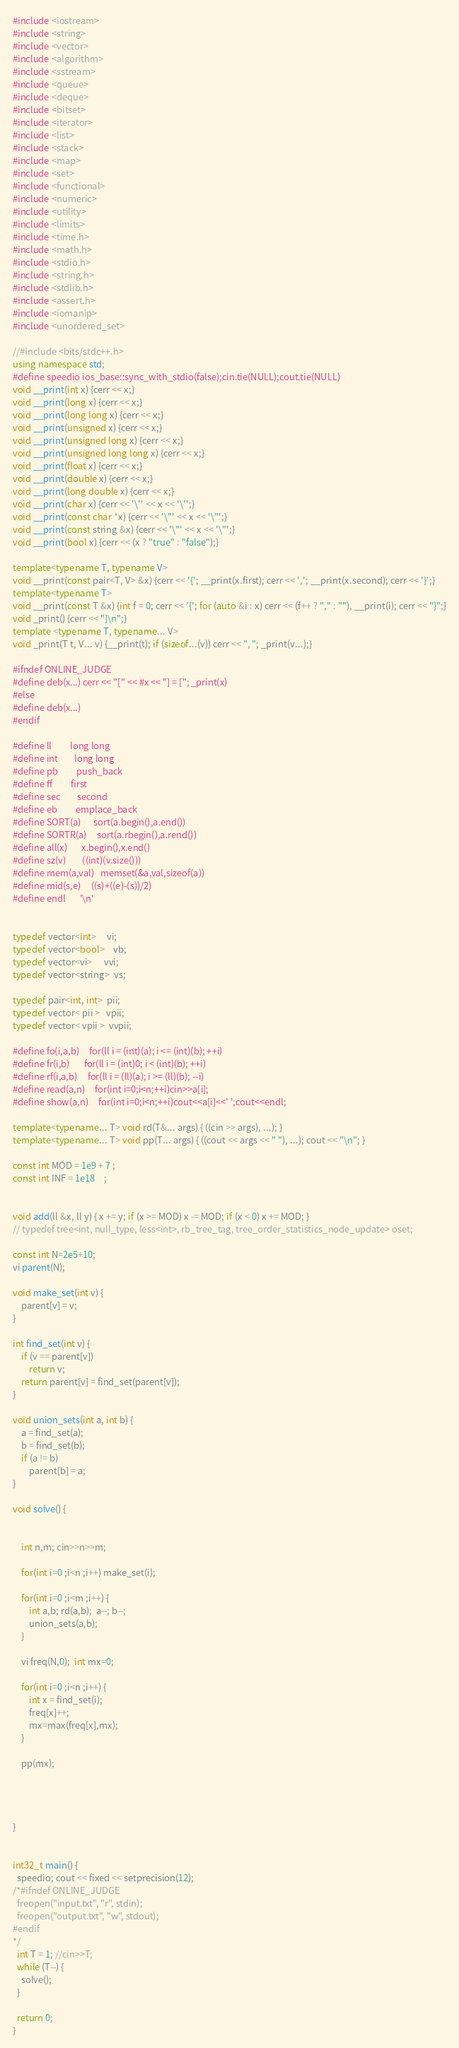<code> <loc_0><loc_0><loc_500><loc_500><_C++_>#include <iostream>
#include <string>
#include <vector>
#include <algorithm>
#include <sstream>
#include <queue>
#include <deque>
#include <bitset>
#include <iterator>
#include <list>
#include <stack>
#include <map>
#include <set>
#include <functional>
#include <numeric>
#include <utility>
#include <limits>
#include <time.h>
#include <math.h>
#include <stdio.h>
#include <string.h>
#include <stdlib.h>
#include <assert.h>
#include <iomanip>
#include <unordered_set> 

//#include <bits/stdc++.h>
using namespace std;
#define speedio ios_base::sync_with_stdio(false);cin.tie(NULL);cout.tie(NULL)
void __print(int x) {cerr << x;}
void __print(long x) {cerr << x;}
void __print(long long x) {cerr << x;}
void __print(unsigned x) {cerr << x;}
void __print(unsigned long x) {cerr << x;}
void __print(unsigned long long x) {cerr << x;}
void __print(float x) {cerr << x;}
void __print(double x) {cerr << x;}
void __print(long double x) {cerr << x;}
void __print(char x) {cerr << '\'' << x << '\'';}
void __print(const char *x) {cerr << '\"' << x << '\"';}
void __print(const string &x) {cerr << '\"' << x << '\"';}
void __print(bool x) {cerr << (x ? "true" : "false");}

template<typename T, typename V>
void __print(const pair<T, V> &x) {cerr << '{'; __print(x.first); cerr << ','; __print(x.second); cerr << '}';}
template<typename T>
void __print(const T &x) {int f = 0; cerr << '{'; for (auto &i : x) cerr << (f++ ? "," : ""), __print(i); cerr << "}";}
void _print() {cerr << "]\n";}
template <typename T, typename... V>
void _print(T t, V... v) {__print(t); if (sizeof...(v)) cerr << ", "; _print(v...);}

#ifndef ONLINE_JUDGE
#define deb(x...) cerr << "[" << #x << "] = ["; _print(x)
#else
#define deb(x...)
#endif

#define ll         long long
#define int        long long
#define pb         push_back
#define ff         first
#define sec        second
#define eb         emplace_back
#define SORT(a)      sort(a.begin(),a.end())
#define SORTR(a)     sort(a.rbegin(),a.rend())
#define all(x)       x.begin(),x.end()
#define sz(v)        ((int)(v.size()))
#define mem(a,val)   memset(&a,val,sizeof(a))
#define mid(s,e)     ((s)+((e)-(s))/2)
#define endl       '\n'


typedef vector<int>     vi;
typedef vector<bool>    vb;
typedef vector<vi>      vvi;
typedef vector<string>  vs;

typedef pair<int, int>  pii;
typedef vector< pii >   vpii;
typedef vector< vpii >  vvpii;

#define fo(i,a,b)     for(ll i = (int)(a); i <= (int)(b); ++i)
#define fr(i,b)       for(ll i = (int)0; i < (int)(b); ++i)
#define rf(i,a,b)     for(ll i = (ll)(a); i >= (ll)(b); --i)
#define read(a,n)     for(int i=0;i<n;++i)cin>>a[i];
#define show(a,n)     for(int i=0;i<n;++i)cout<<a[i]<<' ';cout<<endl;

template<typename... T> void rd(T&... args) { ((cin >> args), ...); }
template<typename... T> void pp(T... args) { ((cout << args << " "), ...); cout << "\n"; }

const int MOD = 1e9 + 7 ;
const int INF = 1e18    ;


void add(ll &x, ll y) { x += y; if (x >= MOD) x -= MOD; if (x < 0) x += MOD; }
// typedef tree<int, null_type, less<int>, rb_tree_tag, tree_order_statistics_node_update> oset;

const int N=2e5+10; 
vi parent(N); 

void make_set(int v) {
    parent[v] = v;
}

int find_set(int v) {
    if (v == parent[v])
        return v;
    return parent[v] = find_set(parent[v]);
}

void union_sets(int a, int b) {
    a = find_set(a);
    b = find_set(b);
    if (a != b)
        parent[b] = a;
}

void solve() {


	int n,m; cin>>n>>m; 

	for(int i=0 ;i<n ;i++) make_set(i); 

	for(int i=0 ;i<m ;i++) {
		int a,b; rd(a,b);  a--; b--; 
		union_sets(a,b); 
	}

	vi freq(N,0);  int mx=0; 
	
	for(int i=0 ;i<n ;i++) {
		int x = find_set(i); 
		freq[x]++; 
		mx=max(freq[x],mx); 
	}

	pp(mx); 




}


int32_t main() {
  speedio; cout << fixed << setprecision(12);
/*#ifndef ONLINE_JUDGE
  freopen("input.txt", "r", stdin);
  freopen("output.txt", "w", stdout);
#endif
*/
  int T = 1; //cin>>T;
  while (T--) {
    solve();
  }

  return 0;
}





</code> 